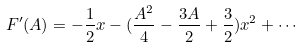Convert formula to latex. <formula><loc_0><loc_0><loc_500><loc_500>F ^ { \prime } ( A ) = - \frac { 1 } { 2 } x - ( \frac { A ^ { 2 } } { 4 } - \frac { 3 A } { 2 } + \frac { 3 } { 2 } ) x ^ { 2 } + \cdots</formula> 